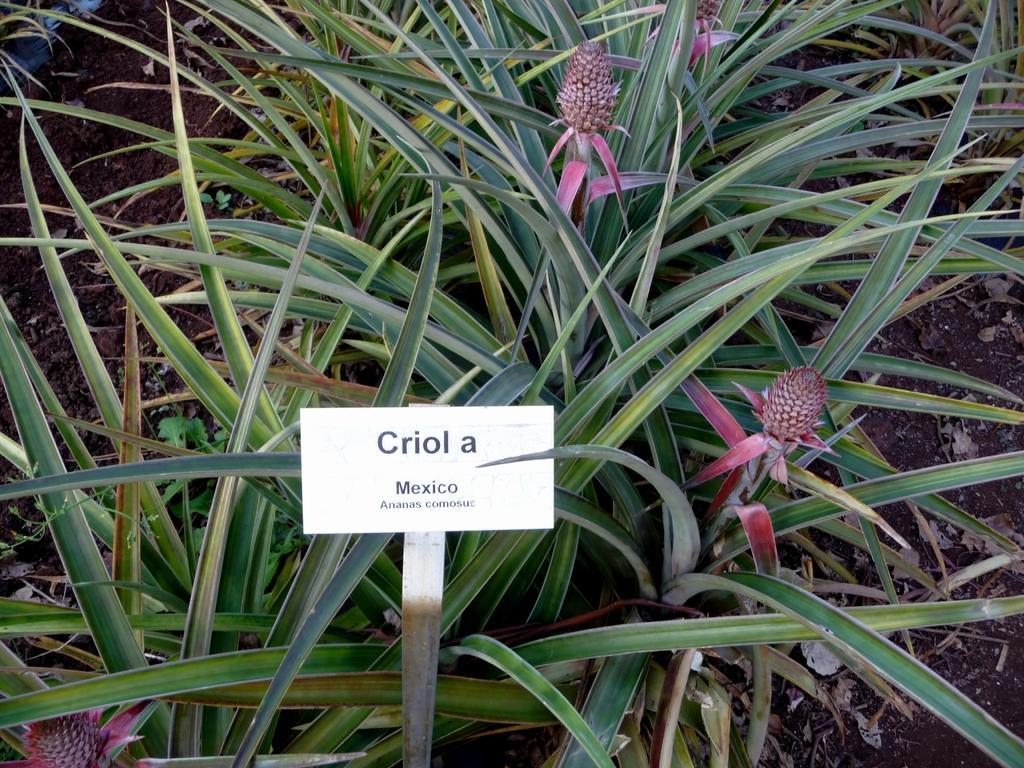How would you summarize this image in a sentence or two? In this image there are plants on the ground. In front of the plants there is a board. There is text on the board. 